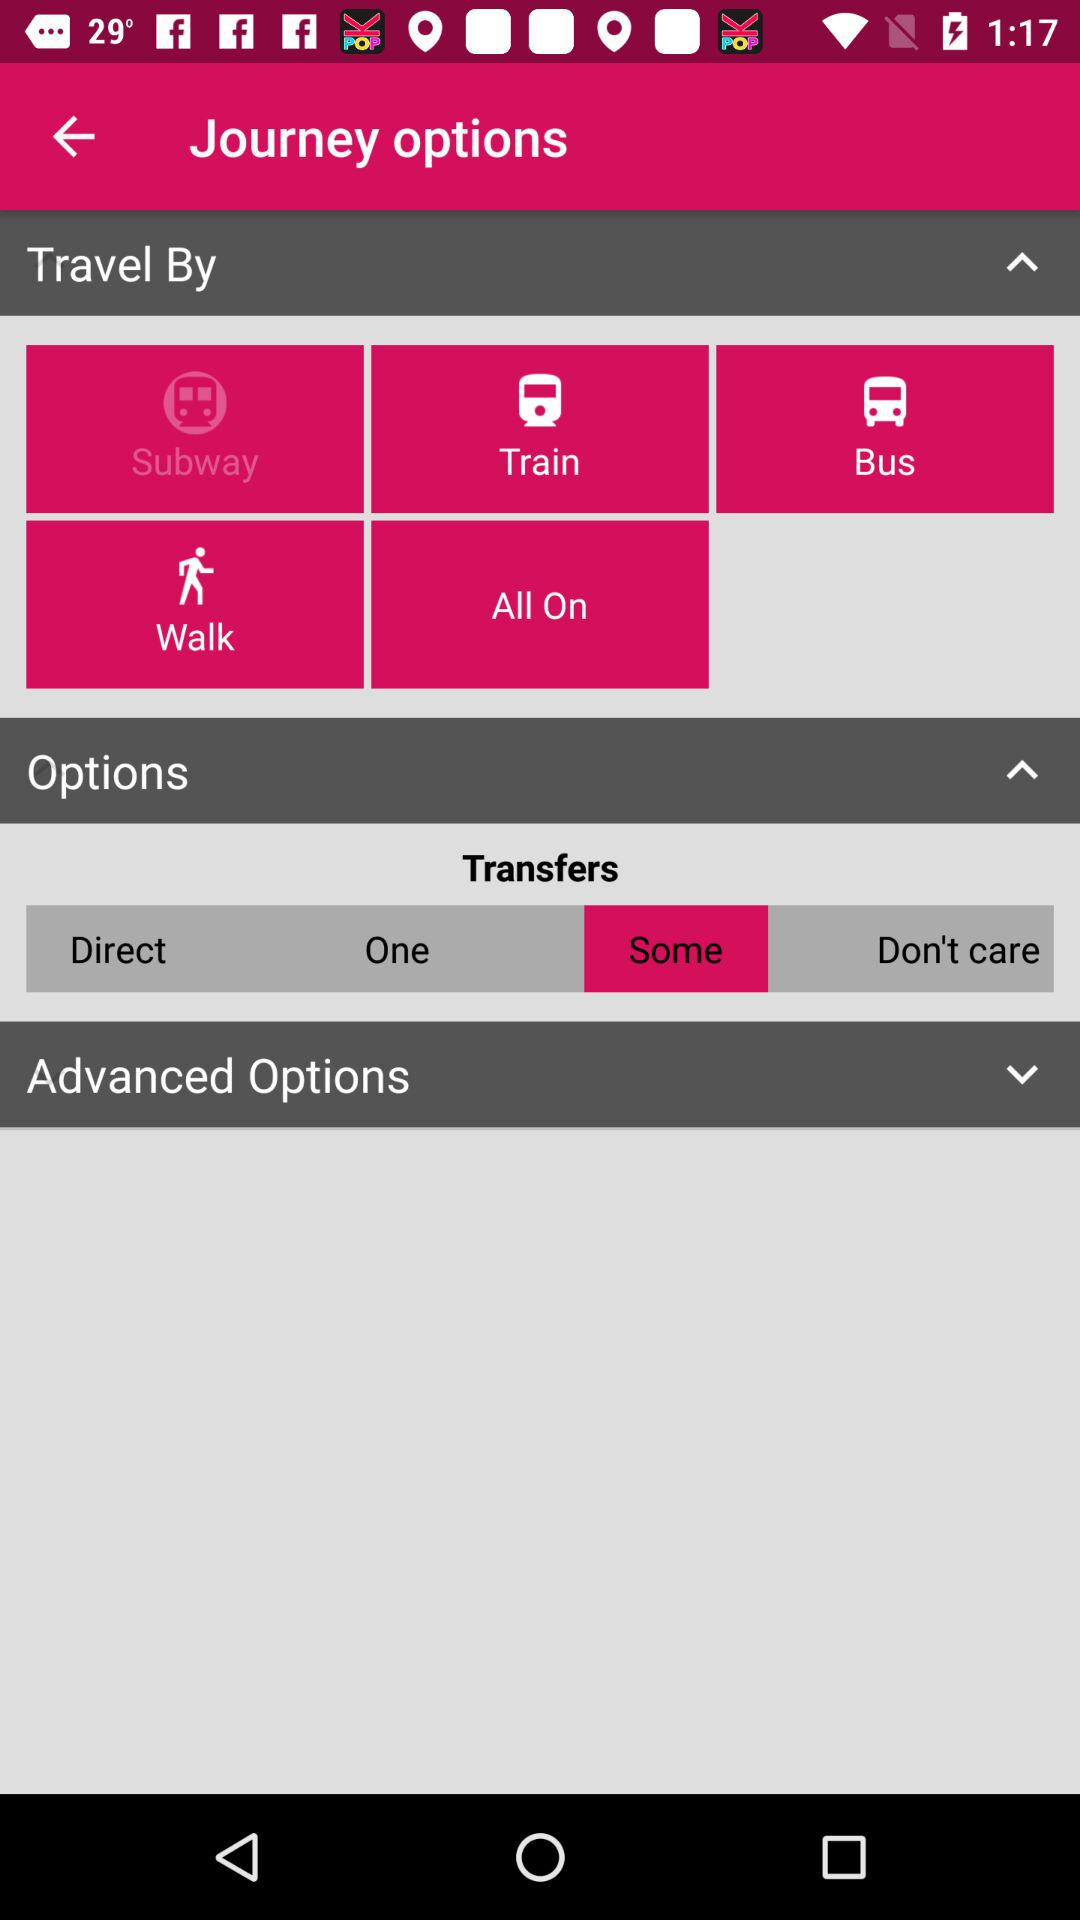Which option is selected in "Travel By"? The selected option is "Subway". 